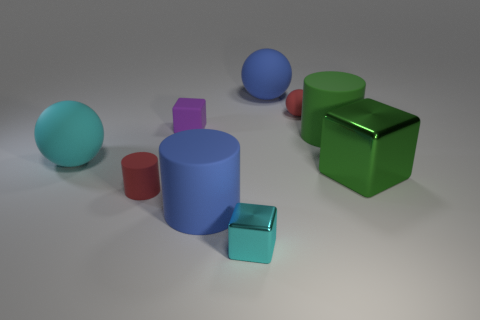Subtract all big rubber cylinders. How many cylinders are left? 1 Add 1 red matte cylinders. How many objects exist? 10 Subtract all tiny rubber things. Subtract all shiny blocks. How many objects are left? 4 Add 8 matte blocks. How many matte blocks are left? 9 Add 2 tiny purple rubber objects. How many tiny purple rubber objects exist? 3 Subtract all cyan spheres. How many spheres are left? 2 Subtract 0 gray cylinders. How many objects are left? 9 Subtract all cubes. How many objects are left? 6 Subtract 2 spheres. How many spheres are left? 1 Subtract all blue balls. Subtract all green cubes. How many balls are left? 2 